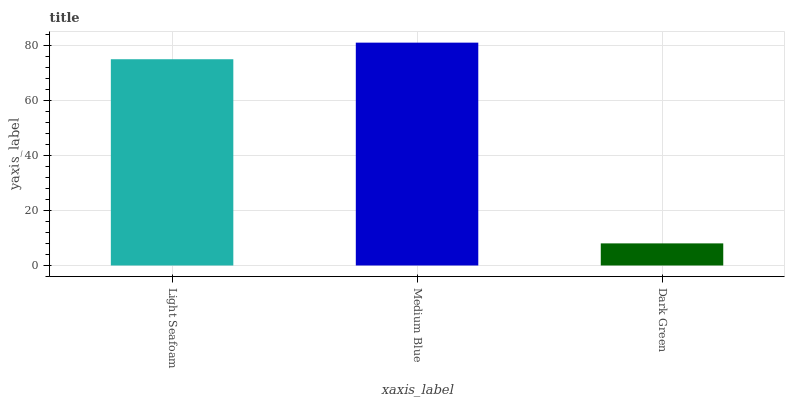Is Dark Green the minimum?
Answer yes or no. Yes. Is Medium Blue the maximum?
Answer yes or no. Yes. Is Medium Blue the minimum?
Answer yes or no. No. Is Dark Green the maximum?
Answer yes or no. No. Is Medium Blue greater than Dark Green?
Answer yes or no. Yes. Is Dark Green less than Medium Blue?
Answer yes or no. Yes. Is Dark Green greater than Medium Blue?
Answer yes or no. No. Is Medium Blue less than Dark Green?
Answer yes or no. No. Is Light Seafoam the high median?
Answer yes or no. Yes. Is Light Seafoam the low median?
Answer yes or no. Yes. Is Dark Green the high median?
Answer yes or no. No. Is Dark Green the low median?
Answer yes or no. No. 